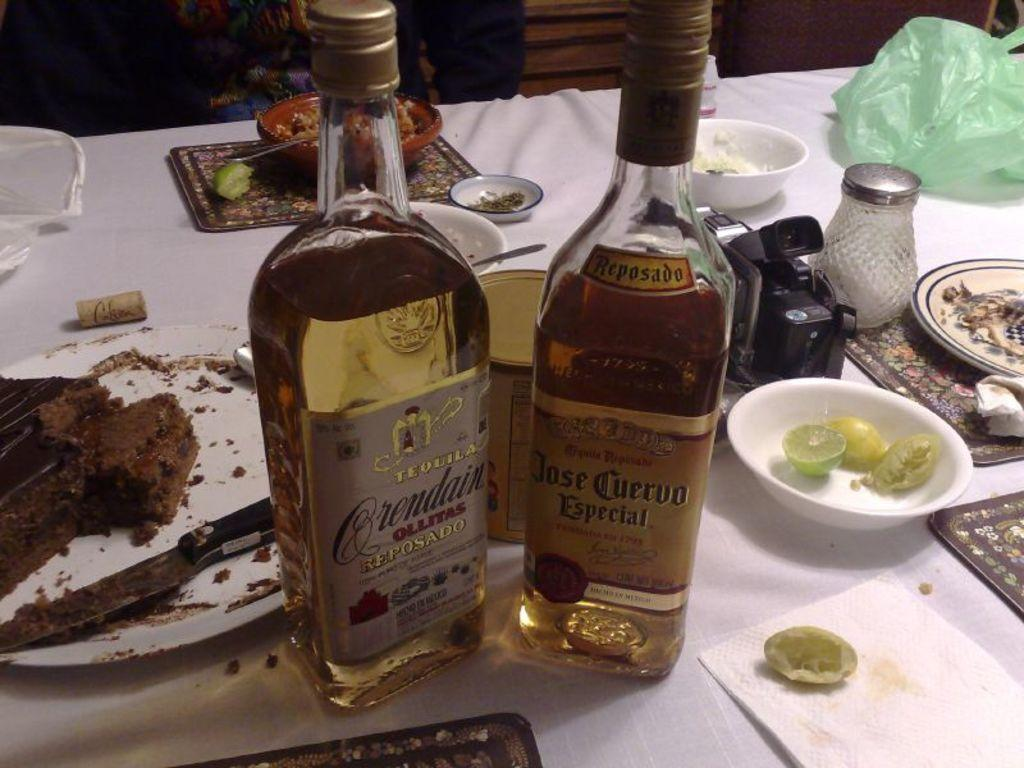<image>
Offer a succinct explanation of the picture presented. Plates of food on a table as well as two bottles of liquor including Jose Cuervo Especial. 